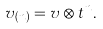Convert formula to latex. <formula><loc_0><loc_0><loc_500><loc_500>v _ { ( n ) } = v \otimes t ^ { n } .</formula> 